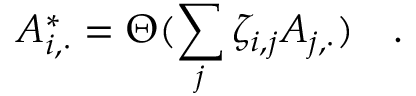Convert formula to latex. <formula><loc_0><loc_0><loc_500><loc_500>A _ { i , \cdot } ^ { \ast } = \Theta ( \sum _ { j } \zeta _ { i , j } A _ { j , \cdot } ) \quad .</formula> 